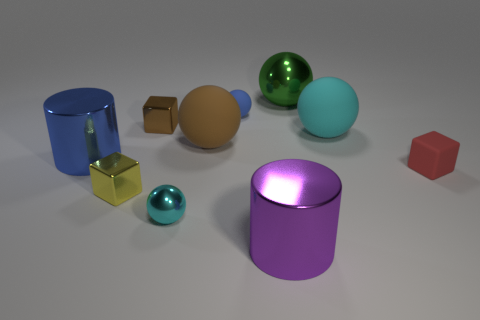There is a thing that is the same color as the tiny metallic sphere; what shape is it?
Provide a succinct answer. Sphere. There is a metallic thing that is the same color as the tiny matte sphere; what size is it?
Offer a terse response. Large. What is the shape of the tiny matte thing that is to the right of the shiny cylinder to the right of the small rubber thing that is behind the large cyan object?
Ensure brevity in your answer.  Cube. There is a green metallic object; what number of large cyan matte objects are on the left side of it?
Offer a very short reply. 0. Does the sphere that is behind the blue matte ball have the same material as the tiny cyan ball?
Offer a terse response. Yes. How many other objects are the same shape as the small cyan shiny thing?
Give a very brief answer. 4. There is a large metallic cylinder that is behind the metal sphere that is in front of the tiny yellow block; what number of large blue things are behind it?
Make the answer very short. 0. What is the color of the shiny ball that is on the right side of the big purple cylinder?
Ensure brevity in your answer.  Green. There is a large cylinder left of the tiny blue thing; is it the same color as the small matte sphere?
Your response must be concise. Yes. What is the size of the green object that is the same shape as the tiny blue object?
Provide a short and direct response. Large. 